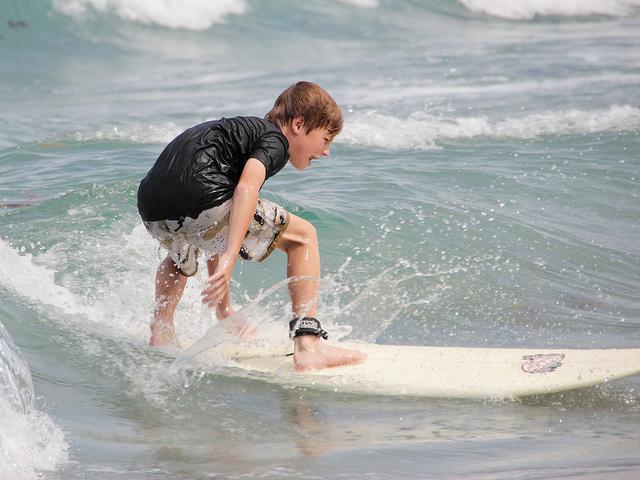How many kites are flying?
Give a very brief answer. 0. 